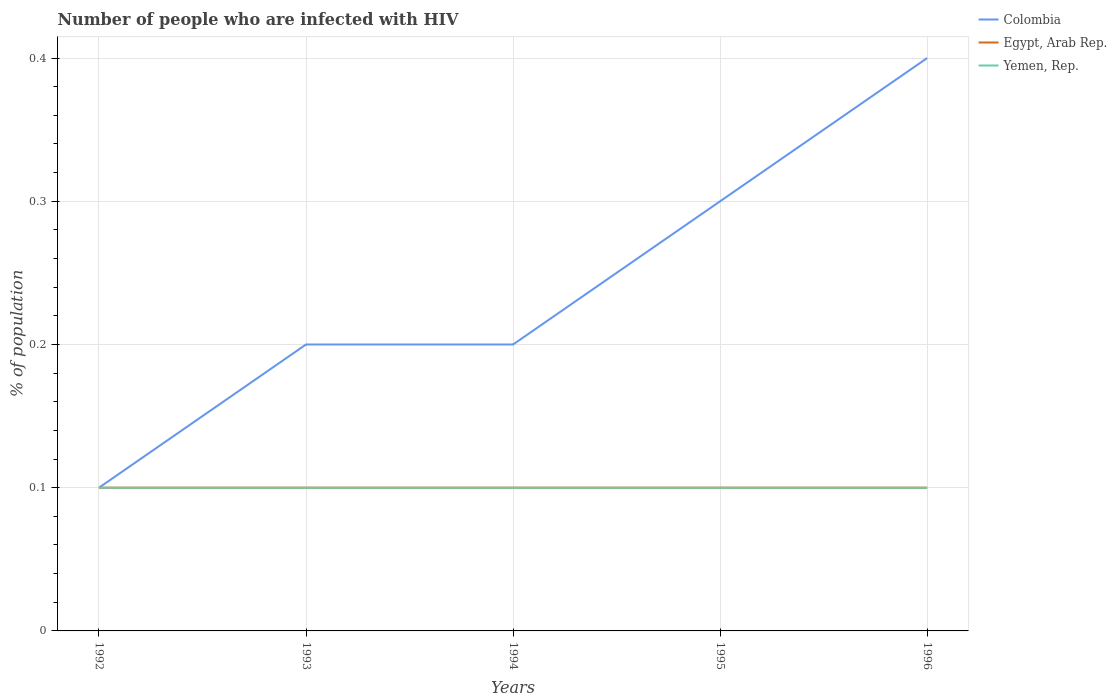How many different coloured lines are there?
Ensure brevity in your answer.  3. Does the line corresponding to Egypt, Arab Rep. intersect with the line corresponding to Yemen, Rep.?
Provide a short and direct response. Yes. Across all years, what is the maximum percentage of HIV infected population in in Yemen, Rep.?
Your response must be concise. 0.1. What is the difference between the highest and the second highest percentage of HIV infected population in in Yemen, Rep.?
Make the answer very short. 0. What is the difference between the highest and the lowest percentage of HIV infected population in in Yemen, Rep.?
Keep it short and to the point. 0. How many years are there in the graph?
Give a very brief answer. 5. What is the difference between two consecutive major ticks on the Y-axis?
Make the answer very short. 0.1. Are the values on the major ticks of Y-axis written in scientific E-notation?
Make the answer very short. No. Does the graph contain any zero values?
Keep it short and to the point. No. Does the graph contain grids?
Ensure brevity in your answer.  Yes. Where does the legend appear in the graph?
Make the answer very short. Top right. How many legend labels are there?
Your response must be concise. 3. How are the legend labels stacked?
Offer a terse response. Vertical. What is the title of the graph?
Make the answer very short. Number of people who are infected with HIV. Does "Cabo Verde" appear as one of the legend labels in the graph?
Make the answer very short. No. What is the label or title of the X-axis?
Give a very brief answer. Years. What is the label or title of the Y-axis?
Keep it short and to the point. % of population. What is the % of population in Colombia in 1992?
Your answer should be compact. 0.1. What is the % of population in Egypt, Arab Rep. in 1992?
Your answer should be compact. 0.1. What is the % of population in Yemen, Rep. in 1992?
Your response must be concise. 0.1. What is the % of population of Egypt, Arab Rep. in 1993?
Your answer should be very brief. 0.1. What is the % of population in Colombia in 1994?
Give a very brief answer. 0.2. What is the % of population in Colombia in 1995?
Offer a terse response. 0.3. What is the % of population in Egypt, Arab Rep. in 1995?
Provide a succinct answer. 0.1. What is the % of population of Yemen, Rep. in 1995?
Offer a terse response. 0.1. What is the % of population in Colombia in 1996?
Your response must be concise. 0.4. Across all years, what is the maximum % of population of Colombia?
Make the answer very short. 0.4. Across all years, what is the maximum % of population in Egypt, Arab Rep.?
Your answer should be very brief. 0.1. Across all years, what is the minimum % of population in Yemen, Rep.?
Keep it short and to the point. 0.1. What is the total % of population in Egypt, Arab Rep. in the graph?
Offer a very short reply. 0.5. What is the total % of population in Yemen, Rep. in the graph?
Make the answer very short. 0.5. What is the difference between the % of population of Colombia in 1992 and that in 1993?
Give a very brief answer. -0.1. What is the difference between the % of population in Egypt, Arab Rep. in 1992 and that in 1993?
Your answer should be compact. 0. What is the difference between the % of population of Yemen, Rep. in 1992 and that in 1993?
Your answer should be very brief. 0. What is the difference between the % of population in Yemen, Rep. in 1992 and that in 1994?
Ensure brevity in your answer.  0. What is the difference between the % of population of Colombia in 1992 and that in 1995?
Keep it short and to the point. -0.2. What is the difference between the % of population in Egypt, Arab Rep. in 1992 and that in 1995?
Offer a very short reply. 0. What is the difference between the % of population of Colombia in 1992 and that in 1996?
Ensure brevity in your answer.  -0.3. What is the difference between the % of population in Yemen, Rep. in 1992 and that in 1996?
Provide a succinct answer. 0. What is the difference between the % of population of Egypt, Arab Rep. in 1993 and that in 1994?
Make the answer very short. 0. What is the difference between the % of population of Yemen, Rep. in 1993 and that in 1994?
Offer a very short reply. 0. What is the difference between the % of population in Colombia in 1993 and that in 1995?
Keep it short and to the point. -0.1. What is the difference between the % of population in Egypt, Arab Rep. in 1993 and that in 1996?
Make the answer very short. 0. What is the difference between the % of population in Egypt, Arab Rep. in 1994 and that in 1995?
Your answer should be very brief. 0. What is the difference between the % of population in Yemen, Rep. in 1994 and that in 1995?
Your response must be concise. 0. What is the difference between the % of population in Egypt, Arab Rep. in 1994 and that in 1996?
Give a very brief answer. 0. What is the difference between the % of population in Yemen, Rep. in 1994 and that in 1996?
Make the answer very short. 0. What is the difference between the % of population of Egypt, Arab Rep. in 1995 and that in 1996?
Your response must be concise. 0. What is the difference between the % of population of Colombia in 1992 and the % of population of Egypt, Arab Rep. in 1993?
Provide a short and direct response. 0. What is the difference between the % of population of Colombia in 1992 and the % of population of Yemen, Rep. in 1993?
Keep it short and to the point. 0. What is the difference between the % of population of Egypt, Arab Rep. in 1992 and the % of population of Yemen, Rep. in 1993?
Offer a terse response. 0. What is the difference between the % of population of Colombia in 1992 and the % of population of Egypt, Arab Rep. in 1994?
Give a very brief answer. 0. What is the difference between the % of population of Colombia in 1992 and the % of population of Yemen, Rep. in 1995?
Provide a short and direct response. 0. What is the difference between the % of population of Colombia in 1992 and the % of population of Egypt, Arab Rep. in 1996?
Offer a very short reply. 0. What is the difference between the % of population of Colombia in 1992 and the % of population of Yemen, Rep. in 1996?
Your response must be concise. 0. What is the difference between the % of population in Egypt, Arab Rep. in 1992 and the % of population in Yemen, Rep. in 1996?
Make the answer very short. 0. What is the difference between the % of population in Colombia in 1993 and the % of population in Yemen, Rep. in 1994?
Your answer should be very brief. 0.1. What is the difference between the % of population of Colombia in 1993 and the % of population of Egypt, Arab Rep. in 1995?
Give a very brief answer. 0.1. What is the difference between the % of population of Colombia in 1993 and the % of population of Egypt, Arab Rep. in 1996?
Offer a terse response. 0.1. What is the difference between the % of population of Egypt, Arab Rep. in 1993 and the % of population of Yemen, Rep. in 1996?
Ensure brevity in your answer.  0. What is the difference between the % of population in Colombia in 1994 and the % of population in Egypt, Arab Rep. in 1995?
Your answer should be very brief. 0.1. What is the difference between the % of population in Egypt, Arab Rep. in 1994 and the % of population in Yemen, Rep. in 1995?
Offer a terse response. 0. What is the difference between the % of population in Colombia in 1994 and the % of population in Yemen, Rep. in 1996?
Ensure brevity in your answer.  0.1. What is the difference between the % of population in Egypt, Arab Rep. in 1994 and the % of population in Yemen, Rep. in 1996?
Provide a succinct answer. 0. What is the difference between the % of population of Colombia in 1995 and the % of population of Egypt, Arab Rep. in 1996?
Make the answer very short. 0.2. What is the difference between the % of population in Colombia in 1995 and the % of population in Yemen, Rep. in 1996?
Your answer should be very brief. 0.2. What is the difference between the % of population of Egypt, Arab Rep. in 1995 and the % of population of Yemen, Rep. in 1996?
Offer a terse response. 0. What is the average % of population of Colombia per year?
Give a very brief answer. 0.24. What is the average % of population of Egypt, Arab Rep. per year?
Provide a short and direct response. 0.1. In the year 1992, what is the difference between the % of population in Colombia and % of population in Egypt, Arab Rep.?
Ensure brevity in your answer.  0. In the year 1992, what is the difference between the % of population in Colombia and % of population in Yemen, Rep.?
Your answer should be compact. 0. In the year 1993, what is the difference between the % of population of Colombia and % of population of Egypt, Arab Rep.?
Your answer should be very brief. 0.1. In the year 1993, what is the difference between the % of population of Colombia and % of population of Yemen, Rep.?
Your answer should be compact. 0.1. In the year 1994, what is the difference between the % of population in Colombia and % of population in Yemen, Rep.?
Ensure brevity in your answer.  0.1. In the year 1994, what is the difference between the % of population in Egypt, Arab Rep. and % of population in Yemen, Rep.?
Provide a short and direct response. 0. In the year 1995, what is the difference between the % of population of Egypt, Arab Rep. and % of population of Yemen, Rep.?
Your answer should be compact. 0. What is the ratio of the % of population in Yemen, Rep. in 1992 to that in 1993?
Keep it short and to the point. 1. What is the ratio of the % of population of Colombia in 1992 to that in 1994?
Provide a short and direct response. 0.5. What is the ratio of the % of population in Colombia in 1992 to that in 1995?
Give a very brief answer. 0.33. What is the ratio of the % of population in Egypt, Arab Rep. in 1992 to that in 1995?
Your answer should be compact. 1. What is the ratio of the % of population of Egypt, Arab Rep. in 1992 to that in 1996?
Ensure brevity in your answer.  1. What is the ratio of the % of population of Yemen, Rep. in 1992 to that in 1996?
Your response must be concise. 1. What is the ratio of the % of population in Egypt, Arab Rep. in 1993 to that in 1995?
Your answer should be very brief. 1. What is the ratio of the % of population of Colombia in 1993 to that in 1996?
Ensure brevity in your answer.  0.5. What is the ratio of the % of population in Yemen, Rep. in 1994 to that in 1995?
Keep it short and to the point. 1. What is the ratio of the % of population of Colombia in 1994 to that in 1996?
Your answer should be very brief. 0.5. What is the ratio of the % of population in Egypt, Arab Rep. in 1994 to that in 1996?
Your answer should be compact. 1. What is the ratio of the % of population in Yemen, Rep. in 1994 to that in 1996?
Provide a succinct answer. 1. What is the ratio of the % of population of Yemen, Rep. in 1995 to that in 1996?
Your answer should be very brief. 1. What is the difference between the highest and the second highest % of population in Egypt, Arab Rep.?
Provide a succinct answer. 0. What is the difference between the highest and the lowest % of population of Colombia?
Give a very brief answer. 0.3. What is the difference between the highest and the lowest % of population in Yemen, Rep.?
Make the answer very short. 0. 